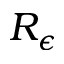<formula> <loc_0><loc_0><loc_500><loc_500>R _ { \epsilon }</formula> 